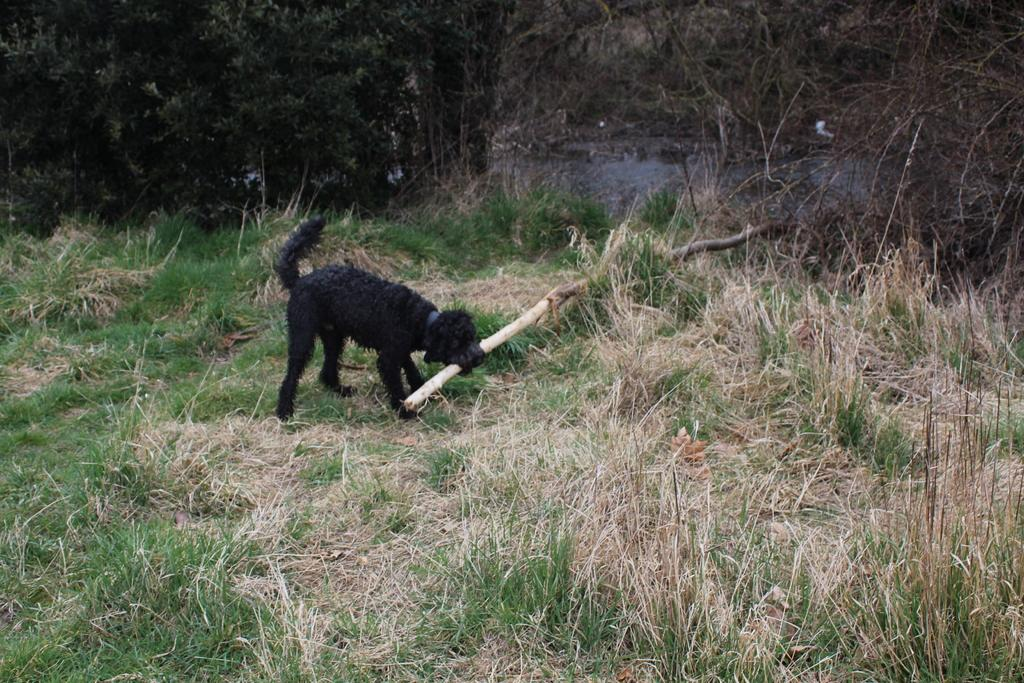What type of animal can be seen in the image? There is an animal in the image, but its specific species cannot be determined from the provided facts. How is the animal interacting with the wooden trunk? The animal is holding a wooden trunk with its mouth. What is the terrain like where the animal is standing? The animal is standing on grassland. What can be seen in the distance behind the animal? There are trees in the background of the image. What type of prison can be seen in the image? There is no prison present in the image; it features an animal holding a wooden trunk on grassland with trees in the background. 